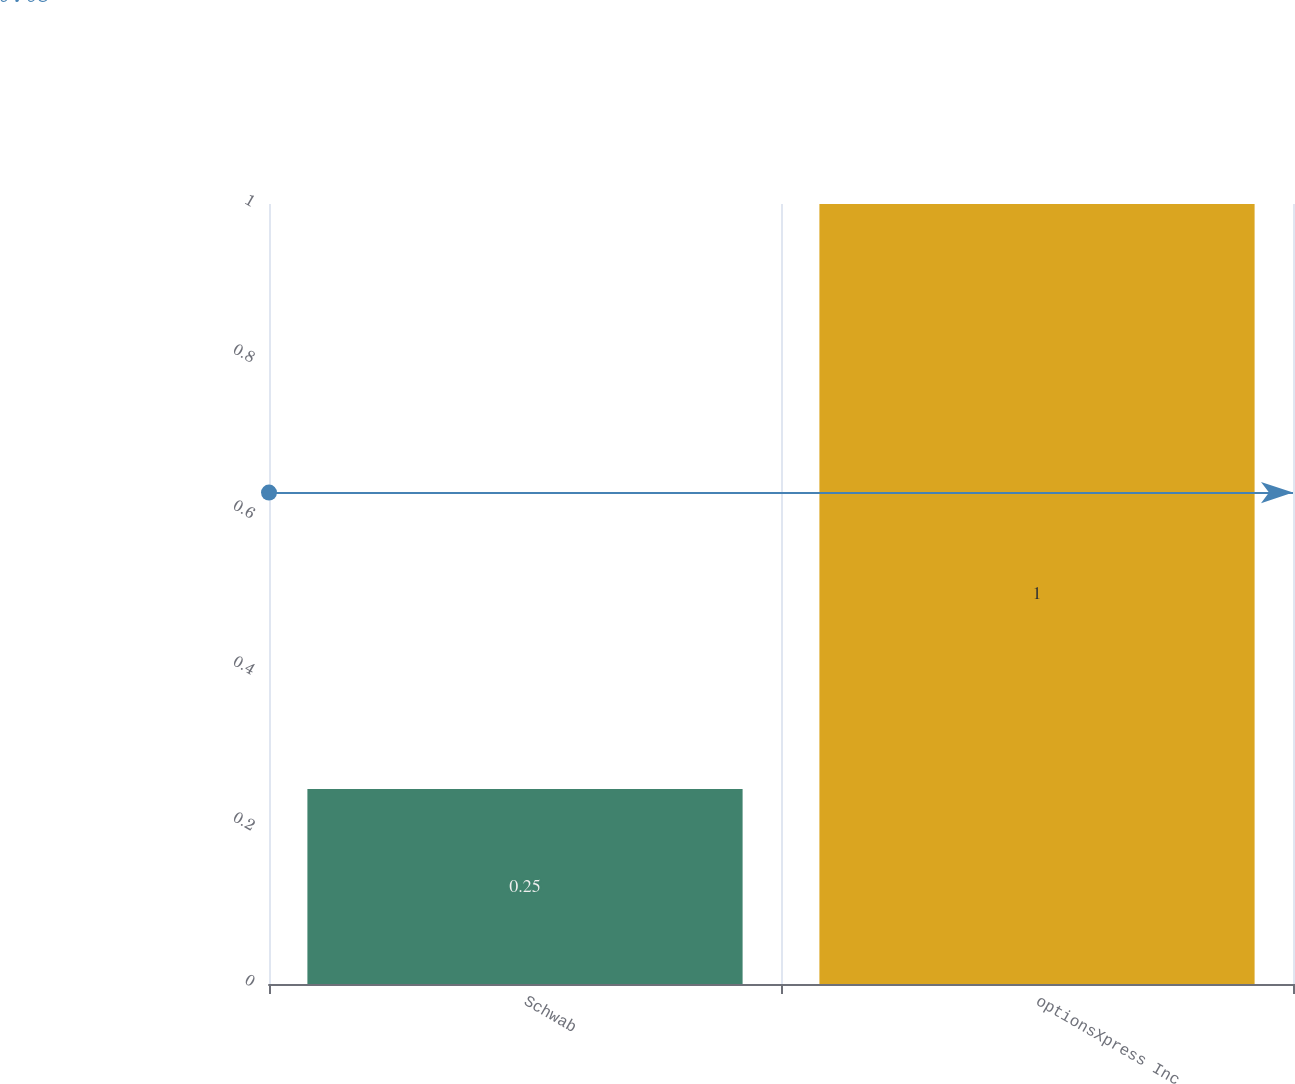<chart> <loc_0><loc_0><loc_500><loc_500><bar_chart><fcel>Schwab<fcel>optionsXpress Inc<nl><fcel>0.25<fcel>1<nl></chart> 